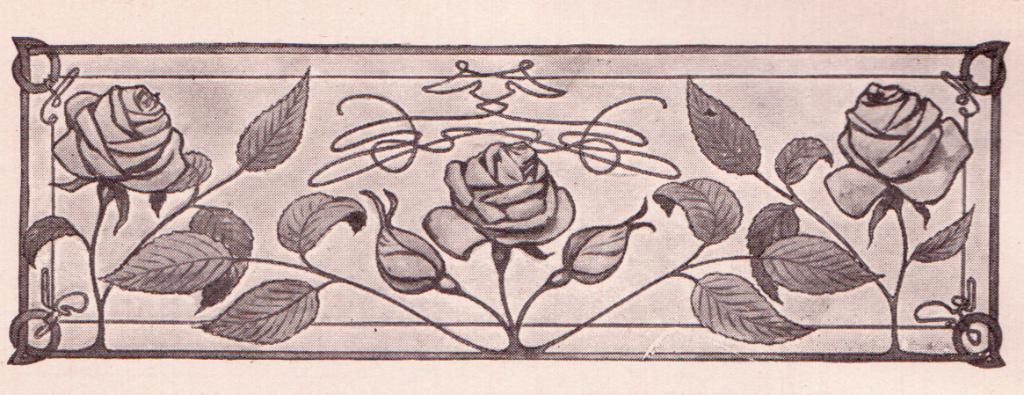Can you describe this image briefly? The picture is a floral design, in the picture there are roses and leaves. 